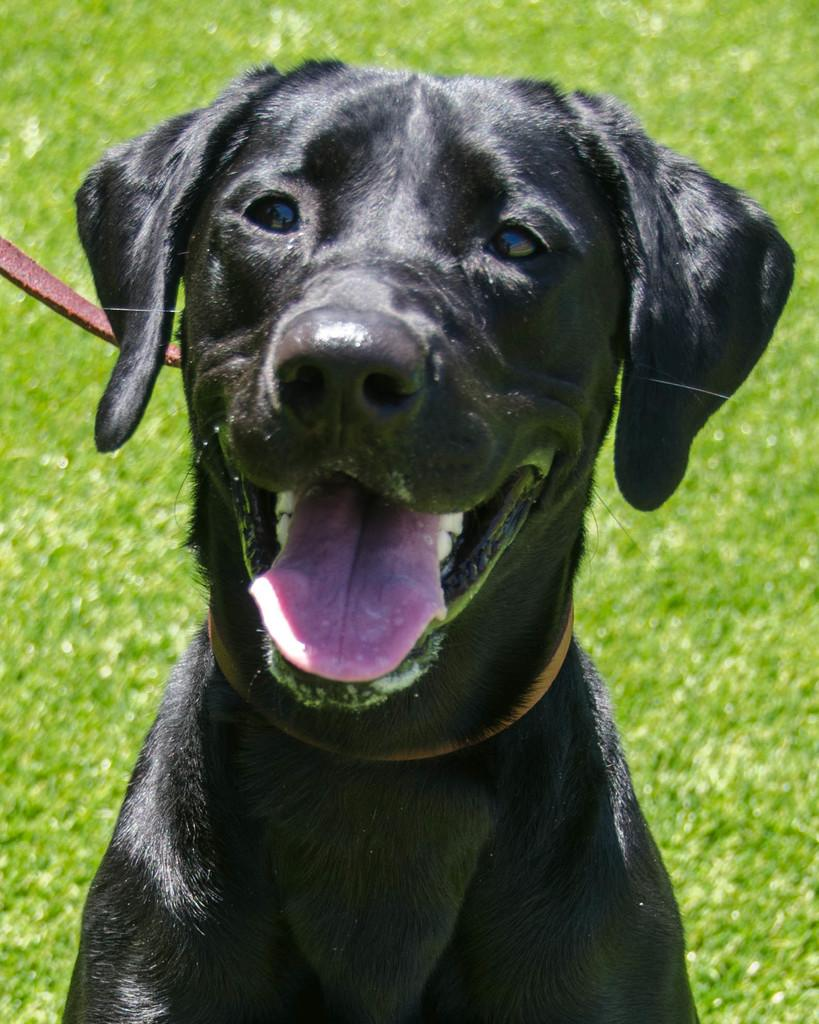What type of surface is visible in the image? The image contains a grass surface. What animal is present in the image? There is a dog in the image. What is the dog doing in the image? The dog is sitting. What is the color of the dog in the image? The dog is black in color. What is the red object around the dog's neck? The dog has a red color belt around its neck. What decision did the dog's owner make regarding the dog's daughter in the image? There is no mention of an owner, daughter, or decision in the image. The image only shows a black dog sitting on a grass surface with a red color belt around its neck. 